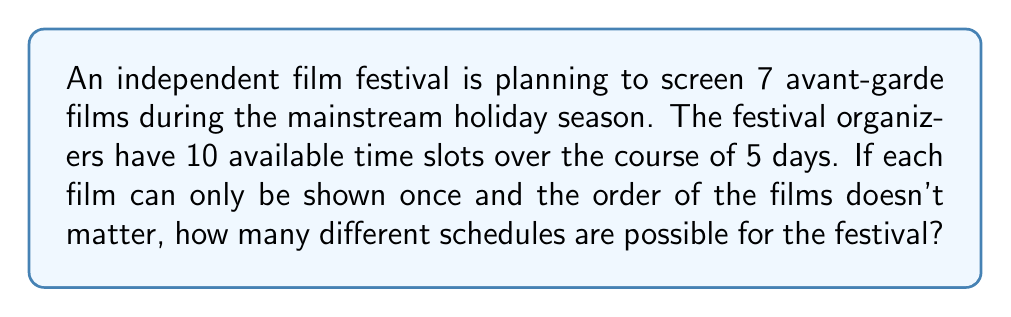Show me your answer to this math problem. Let's approach this step-by-step:

1) This is a combination problem. We need to select 7 time slots out of 10 available slots for the 7 films.

2) The order doesn't matter (we're not concerned with which film goes in which slot, just which slots are filled), so we use the combination formula:

   $$C(n,r) = \frac{n!}{r!(n-r)!}$$

   Where $n$ is the total number of items to choose from, and $r$ is the number of items being chosen.

3) In this case, $n = 10$ (total available time slots) and $r = 7$ (number of films to be screened).

4) Plugging these values into our formula:

   $$C(10,7) = \frac{10!}{7!(10-7)!} = \frac{10!}{7!(3)!}$$

5) Expand this:
   
   $$\frac{10 * 9 * 8 * 7!}{7! * 3 * 2 * 1}$$

6) The 7! cancels out in the numerator and denominator:

   $$\frac{10 * 9 * 8}{3 * 2 * 1} = \frac{720}{6} = 120$$

Therefore, there are 120 possible schedules for the film festival.
Answer: 120 